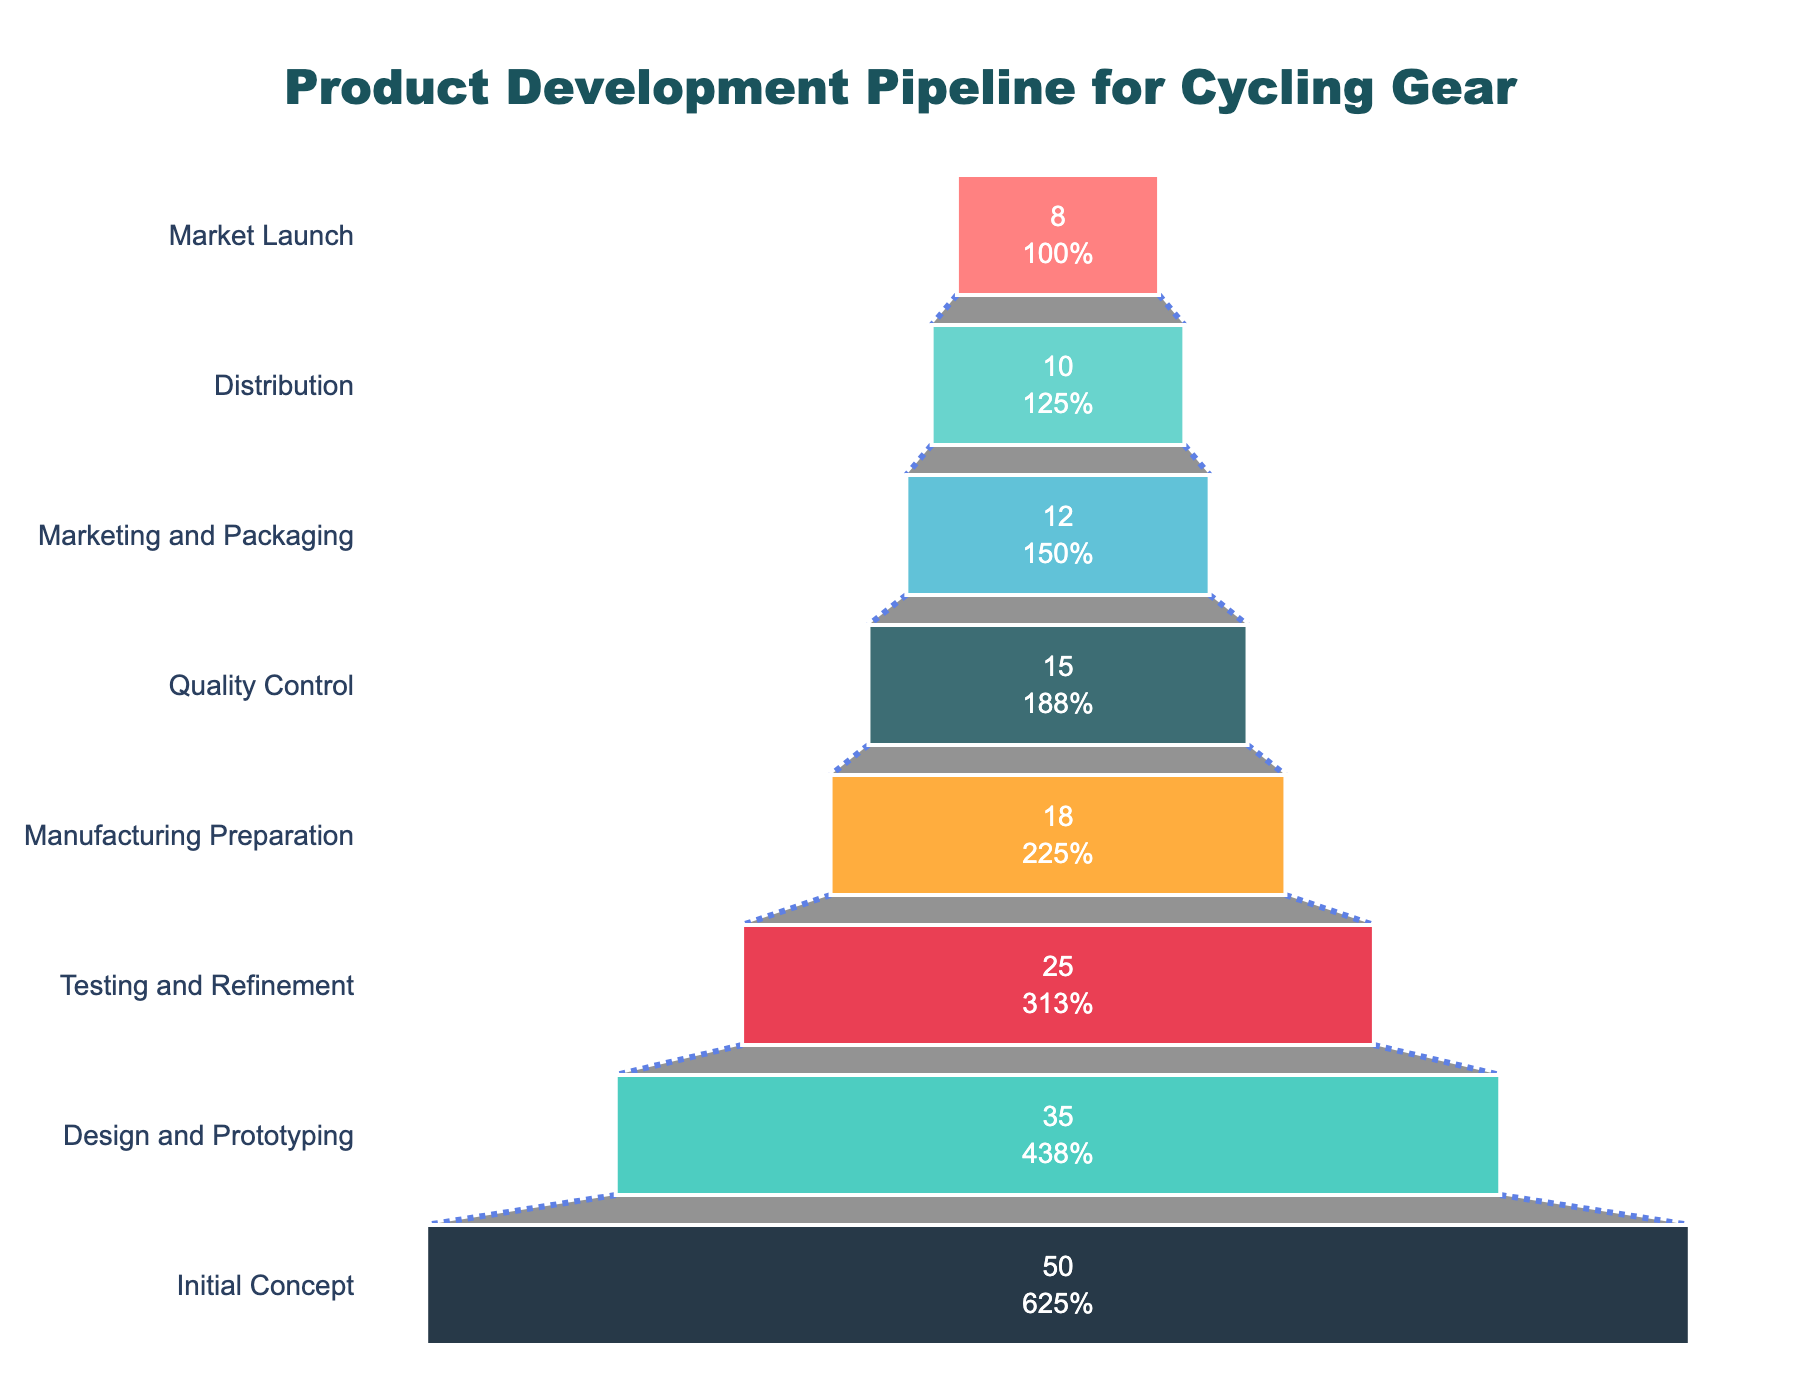What is the title of the funnel chart? The title is located above the funnel chart and provides a summary description of what the chart represents. In this case, it says "Product Development Pipeline for Cycling Gear."
Answer: Product Development Pipeline for Cycling Gear How many stages are there in the funnel from concept to market launch? Count the number of distinct stages listed on the y-axis that represent each step in the product development process.
Answer: 8 Which stage has the highest number of products? The stage with the highest number of products corresponds to the largest segment at the top of the funnel chart.
Answer: Initial Concept What percentage of the initial concept products reach the market launch stage? To find this, divide the number of products that reach the Market Launch stage by the number of products at the Initial Concept stage and multiply by 100. This calculation is (8 / 50) * 100.
Answer: 16% Which stage sees the biggest drop in the number of products compared to the previous stage? Identify the stage with the largest absolute difference in the number of products from the previous stage by examining each successive pair of stages. The difference between Design and Prototyping (35) and Initial Concept (50) is 15, Testing and Refinement (25) and Design and Prototyping (35) is 10, and so on. The largest drop is between Initial Concept and Design and Prototyping.
Answer: Design and Prototyping How many products are there in the Testing and Refinement stage? Look at the number of products listed next to the Testing and Refinement stage on the funnel chart.
Answer: 25 By what percentage do the products decrease from Manufacturing Preparation to Quality Control? Calculate the percentage decrease by taking the difference between the number of products in these two stages, dividing by the number of products in the Manufacturing Preparation stage, and multiplying by 100. This calculation is ((18 - 15) / 18) * 100.
Answer: 16.67% Out of the total number of products at the Design and Prototyping stage, how many product stages lose products before reaching the Market Launch stage? Count the number of stages from Design and Prototyping (inclusive) to Market Launch. This involves Design and Prototyping, Testing and Refinement, Manufacturing Preparation, Quality Control, Marketing and Packaging, Distribution, and Market Launch.
Answer: 7 What is the combined number of products in the final three stages before Market Launch? Sum the number of products in Quality Control, Marketing and Packaging, and Distribution stages. This is 15 + 12 + 10.
Answer: 37 Is the number of products at the Market Launch stage greater than, less than, or equal to the number of products at the Testing and Refinement stage? Compare the number of products directly between these two stages. Market Launch has 8 products, while Testing and Refinement has 25.
Answer: Less than 